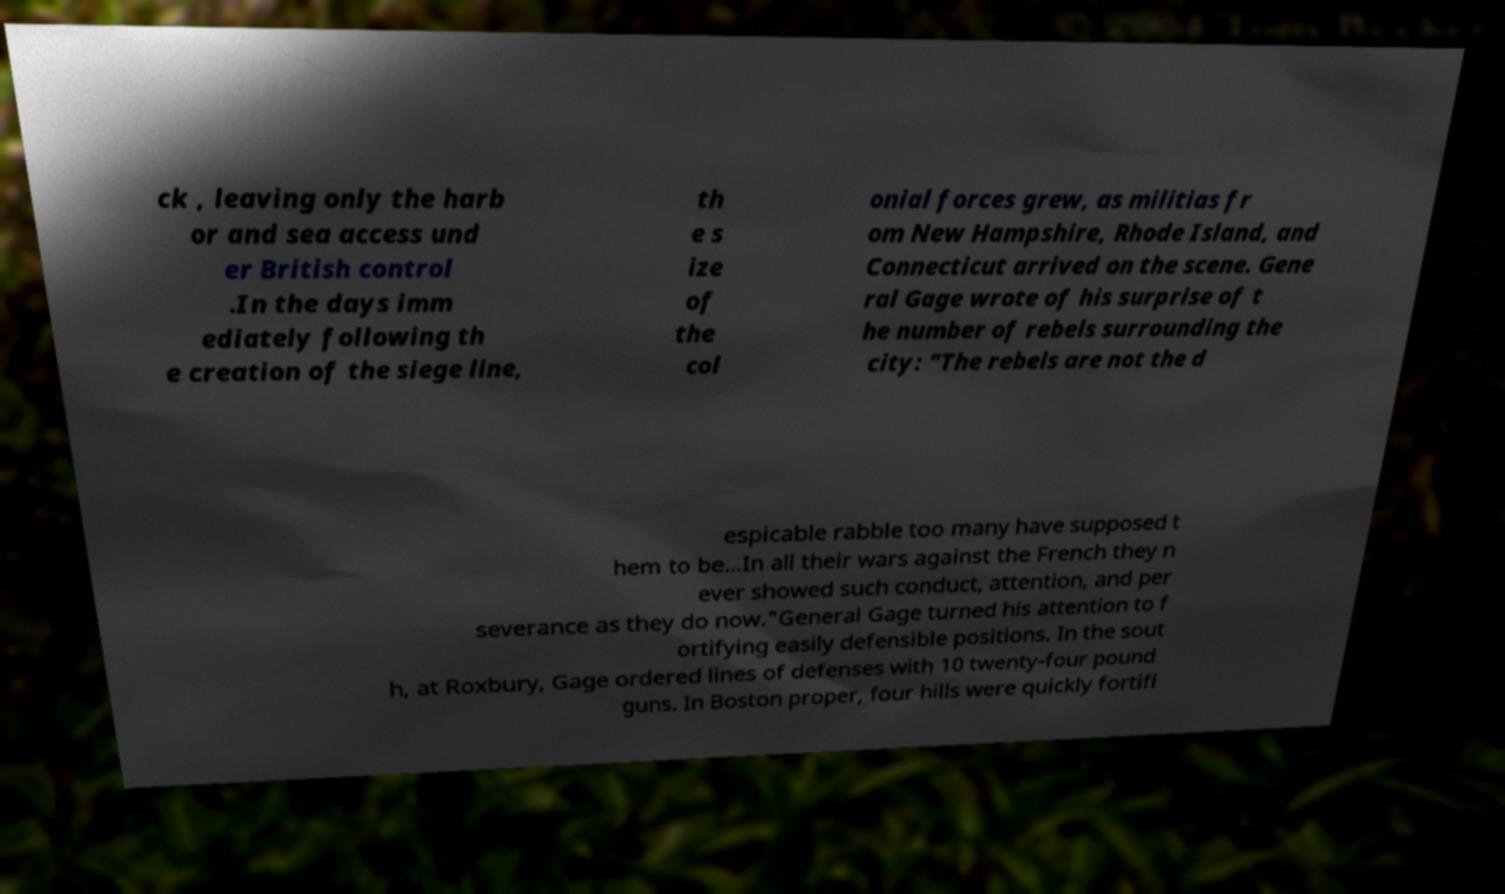Can you read and provide the text displayed in the image?This photo seems to have some interesting text. Can you extract and type it out for me? ck , leaving only the harb or and sea access und er British control .In the days imm ediately following th e creation of the siege line, th e s ize of the col onial forces grew, as militias fr om New Hampshire, Rhode Island, and Connecticut arrived on the scene. Gene ral Gage wrote of his surprise of t he number of rebels surrounding the city: "The rebels are not the d espicable rabble too many have supposed t hem to be...In all their wars against the French they n ever showed such conduct, attention, and per severance as they do now."General Gage turned his attention to f ortifying easily defensible positions. In the sout h, at Roxbury, Gage ordered lines of defenses with 10 twenty-four pound guns. In Boston proper, four hills were quickly fortifi 